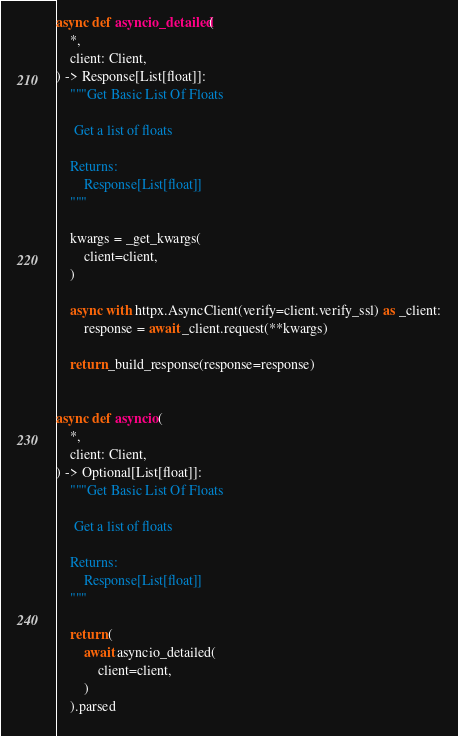<code> <loc_0><loc_0><loc_500><loc_500><_Python_>
async def asyncio_detailed(
    *,
    client: Client,
) -> Response[List[float]]:
    """Get Basic List Of Floats

     Get a list of floats

    Returns:
        Response[List[float]]
    """

    kwargs = _get_kwargs(
        client=client,
    )

    async with httpx.AsyncClient(verify=client.verify_ssl) as _client:
        response = await _client.request(**kwargs)

    return _build_response(response=response)


async def asyncio(
    *,
    client: Client,
) -> Optional[List[float]]:
    """Get Basic List Of Floats

     Get a list of floats

    Returns:
        Response[List[float]]
    """

    return (
        await asyncio_detailed(
            client=client,
        )
    ).parsed
</code> 